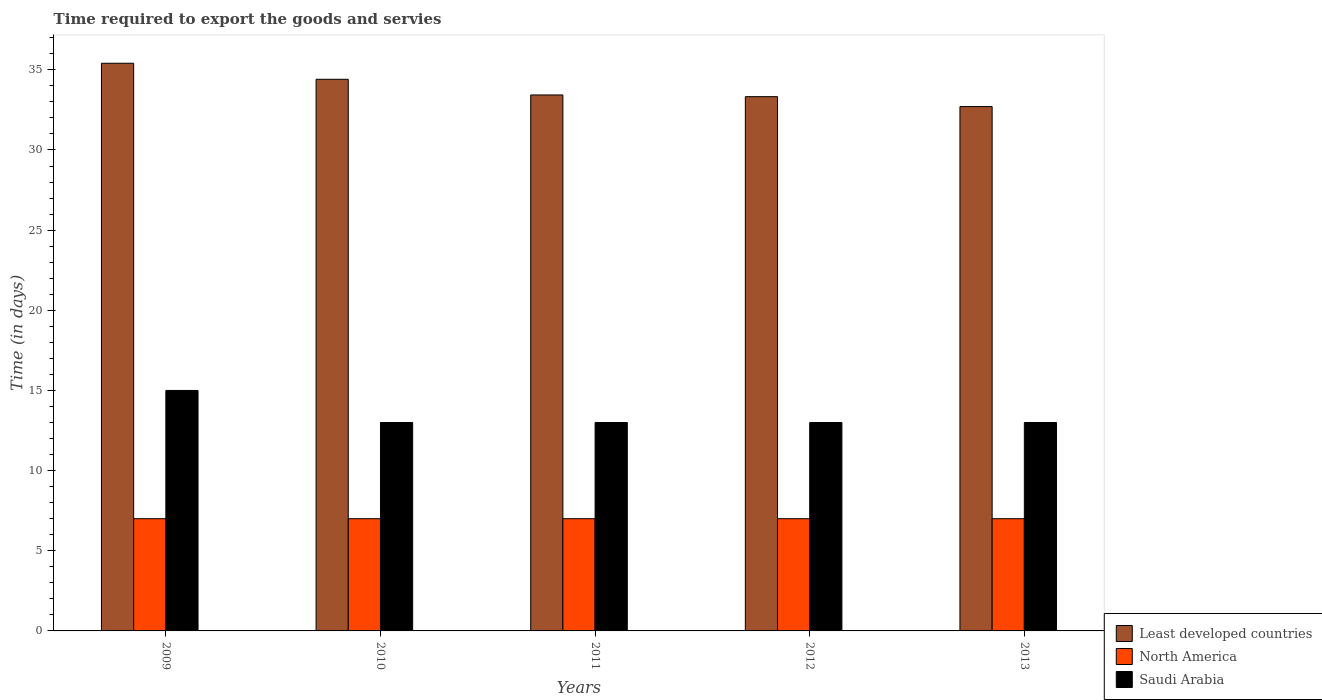How many different coloured bars are there?
Give a very brief answer. 3. How many groups of bars are there?
Keep it short and to the point. 5. Are the number of bars per tick equal to the number of legend labels?
Your answer should be compact. Yes. Are the number of bars on each tick of the X-axis equal?
Your answer should be very brief. Yes. How many bars are there on the 2nd tick from the left?
Your answer should be very brief. 3. What is the number of days required to export the goods and services in North America in 2011?
Keep it short and to the point. 7. Across all years, what is the maximum number of days required to export the goods and services in Saudi Arabia?
Provide a short and direct response. 15. Across all years, what is the minimum number of days required to export the goods and services in Saudi Arabia?
Your response must be concise. 13. In which year was the number of days required to export the goods and services in Saudi Arabia maximum?
Your response must be concise. 2009. In which year was the number of days required to export the goods and services in Saudi Arabia minimum?
Make the answer very short. 2010. What is the total number of days required to export the goods and services in North America in the graph?
Your response must be concise. 35. What is the average number of days required to export the goods and services in Least developed countries per year?
Ensure brevity in your answer.  33.86. In the year 2009, what is the difference between the number of days required to export the goods and services in Saudi Arabia and number of days required to export the goods and services in North America?
Make the answer very short. 8. In how many years, is the number of days required to export the goods and services in Least developed countries greater than 30 days?
Provide a short and direct response. 5. What is the ratio of the number of days required to export the goods and services in Saudi Arabia in 2009 to that in 2012?
Provide a short and direct response. 1.15. What is the difference between the highest and the lowest number of days required to export the goods and services in Saudi Arabia?
Give a very brief answer. 2. Is the sum of the number of days required to export the goods and services in Least developed countries in 2011 and 2012 greater than the maximum number of days required to export the goods and services in Saudi Arabia across all years?
Provide a succinct answer. Yes. What does the 1st bar from the left in 2010 represents?
Keep it short and to the point. Least developed countries. What does the 1st bar from the right in 2011 represents?
Make the answer very short. Saudi Arabia. How many bars are there?
Your answer should be very brief. 15. Are all the bars in the graph horizontal?
Keep it short and to the point. No. How many years are there in the graph?
Your response must be concise. 5. What is the difference between two consecutive major ticks on the Y-axis?
Keep it short and to the point. 5. Are the values on the major ticks of Y-axis written in scientific E-notation?
Provide a succinct answer. No. Does the graph contain any zero values?
Make the answer very short. No. Does the graph contain grids?
Offer a very short reply. No. Where does the legend appear in the graph?
Your response must be concise. Bottom right. How many legend labels are there?
Offer a very short reply. 3. How are the legend labels stacked?
Provide a succinct answer. Vertical. What is the title of the graph?
Provide a short and direct response. Time required to export the goods and servies. What is the label or title of the Y-axis?
Ensure brevity in your answer.  Time (in days). What is the Time (in days) of Least developed countries in 2009?
Ensure brevity in your answer.  35.41. What is the Time (in days) of North America in 2009?
Your answer should be very brief. 7. What is the Time (in days) of Least developed countries in 2010?
Ensure brevity in your answer.  34.41. What is the Time (in days) of North America in 2010?
Your answer should be compact. 7. What is the Time (in days) of Saudi Arabia in 2010?
Provide a short and direct response. 13. What is the Time (in days) in Least developed countries in 2011?
Give a very brief answer. 33.43. What is the Time (in days) of North America in 2011?
Offer a terse response. 7. What is the Time (in days) of Least developed countries in 2012?
Your answer should be very brief. 33.33. What is the Time (in days) in Least developed countries in 2013?
Provide a short and direct response. 32.71. What is the Time (in days) in North America in 2013?
Offer a very short reply. 7. What is the Time (in days) in Saudi Arabia in 2013?
Offer a very short reply. 13. Across all years, what is the maximum Time (in days) in Least developed countries?
Your answer should be very brief. 35.41. Across all years, what is the minimum Time (in days) in Least developed countries?
Keep it short and to the point. 32.71. What is the total Time (in days) in Least developed countries in the graph?
Make the answer very short. 169.28. What is the total Time (in days) of North America in the graph?
Keep it short and to the point. 35. What is the total Time (in days) in Saudi Arabia in the graph?
Your answer should be compact. 67. What is the difference between the Time (in days) in Least developed countries in 2009 and that in 2010?
Keep it short and to the point. 1. What is the difference between the Time (in days) of Saudi Arabia in 2009 and that in 2010?
Provide a succinct answer. 2. What is the difference between the Time (in days) of Least developed countries in 2009 and that in 2011?
Give a very brief answer. 1.98. What is the difference between the Time (in days) of Least developed countries in 2009 and that in 2012?
Ensure brevity in your answer.  2.08. What is the difference between the Time (in days) in Saudi Arabia in 2009 and that in 2012?
Offer a very short reply. 2. What is the difference between the Time (in days) of Least developed countries in 2009 and that in 2013?
Offer a terse response. 2.7. What is the difference between the Time (in days) in North America in 2009 and that in 2013?
Provide a succinct answer. 0. What is the difference between the Time (in days) of Least developed countries in 2010 and that in 2011?
Your answer should be compact. 0.98. What is the difference between the Time (in days) of North America in 2010 and that in 2011?
Make the answer very short. 0. What is the difference between the Time (in days) of Least developed countries in 2010 and that in 2012?
Keep it short and to the point. 1.08. What is the difference between the Time (in days) of Saudi Arabia in 2010 and that in 2012?
Provide a succinct answer. 0. What is the difference between the Time (in days) in Least developed countries in 2010 and that in 2013?
Your answer should be very brief. 1.7. What is the difference between the Time (in days) in Saudi Arabia in 2010 and that in 2013?
Make the answer very short. 0. What is the difference between the Time (in days) in Least developed countries in 2011 and that in 2012?
Offer a terse response. 0.11. What is the difference between the Time (in days) in Saudi Arabia in 2011 and that in 2012?
Offer a terse response. 0. What is the difference between the Time (in days) in Least developed countries in 2011 and that in 2013?
Your answer should be very brief. 0.72. What is the difference between the Time (in days) in North America in 2011 and that in 2013?
Offer a very short reply. 0. What is the difference between the Time (in days) in Least developed countries in 2012 and that in 2013?
Provide a short and direct response. 0.62. What is the difference between the Time (in days) of North America in 2012 and that in 2013?
Make the answer very short. 0. What is the difference between the Time (in days) of Least developed countries in 2009 and the Time (in days) of North America in 2010?
Provide a succinct answer. 28.41. What is the difference between the Time (in days) of Least developed countries in 2009 and the Time (in days) of Saudi Arabia in 2010?
Offer a terse response. 22.41. What is the difference between the Time (in days) in Least developed countries in 2009 and the Time (in days) in North America in 2011?
Offer a very short reply. 28.41. What is the difference between the Time (in days) of Least developed countries in 2009 and the Time (in days) of Saudi Arabia in 2011?
Provide a succinct answer. 22.41. What is the difference between the Time (in days) in Least developed countries in 2009 and the Time (in days) in North America in 2012?
Offer a terse response. 28.41. What is the difference between the Time (in days) in Least developed countries in 2009 and the Time (in days) in Saudi Arabia in 2012?
Give a very brief answer. 22.41. What is the difference between the Time (in days) in North America in 2009 and the Time (in days) in Saudi Arabia in 2012?
Your answer should be very brief. -6. What is the difference between the Time (in days) in Least developed countries in 2009 and the Time (in days) in North America in 2013?
Offer a terse response. 28.41. What is the difference between the Time (in days) in Least developed countries in 2009 and the Time (in days) in Saudi Arabia in 2013?
Ensure brevity in your answer.  22.41. What is the difference between the Time (in days) in Least developed countries in 2010 and the Time (in days) in North America in 2011?
Your response must be concise. 27.41. What is the difference between the Time (in days) in Least developed countries in 2010 and the Time (in days) in Saudi Arabia in 2011?
Offer a very short reply. 21.41. What is the difference between the Time (in days) in North America in 2010 and the Time (in days) in Saudi Arabia in 2011?
Give a very brief answer. -6. What is the difference between the Time (in days) of Least developed countries in 2010 and the Time (in days) of North America in 2012?
Ensure brevity in your answer.  27.41. What is the difference between the Time (in days) in Least developed countries in 2010 and the Time (in days) in Saudi Arabia in 2012?
Offer a terse response. 21.41. What is the difference between the Time (in days) in Least developed countries in 2010 and the Time (in days) in North America in 2013?
Your response must be concise. 27.41. What is the difference between the Time (in days) in Least developed countries in 2010 and the Time (in days) in Saudi Arabia in 2013?
Give a very brief answer. 21.41. What is the difference between the Time (in days) in Least developed countries in 2011 and the Time (in days) in North America in 2012?
Provide a succinct answer. 26.43. What is the difference between the Time (in days) in Least developed countries in 2011 and the Time (in days) in Saudi Arabia in 2012?
Provide a succinct answer. 20.43. What is the difference between the Time (in days) in Least developed countries in 2011 and the Time (in days) in North America in 2013?
Provide a short and direct response. 26.43. What is the difference between the Time (in days) in Least developed countries in 2011 and the Time (in days) in Saudi Arabia in 2013?
Offer a terse response. 20.43. What is the difference between the Time (in days) of Least developed countries in 2012 and the Time (in days) of North America in 2013?
Your answer should be compact. 26.33. What is the difference between the Time (in days) of Least developed countries in 2012 and the Time (in days) of Saudi Arabia in 2013?
Provide a short and direct response. 20.33. What is the difference between the Time (in days) of North America in 2012 and the Time (in days) of Saudi Arabia in 2013?
Ensure brevity in your answer.  -6. What is the average Time (in days) in Least developed countries per year?
Provide a succinct answer. 33.86. What is the average Time (in days) in North America per year?
Give a very brief answer. 7. In the year 2009, what is the difference between the Time (in days) in Least developed countries and Time (in days) in North America?
Provide a short and direct response. 28.41. In the year 2009, what is the difference between the Time (in days) of Least developed countries and Time (in days) of Saudi Arabia?
Offer a terse response. 20.41. In the year 2009, what is the difference between the Time (in days) of North America and Time (in days) of Saudi Arabia?
Your answer should be very brief. -8. In the year 2010, what is the difference between the Time (in days) of Least developed countries and Time (in days) of North America?
Provide a short and direct response. 27.41. In the year 2010, what is the difference between the Time (in days) in Least developed countries and Time (in days) in Saudi Arabia?
Offer a terse response. 21.41. In the year 2010, what is the difference between the Time (in days) in North America and Time (in days) in Saudi Arabia?
Your answer should be compact. -6. In the year 2011, what is the difference between the Time (in days) in Least developed countries and Time (in days) in North America?
Offer a very short reply. 26.43. In the year 2011, what is the difference between the Time (in days) in Least developed countries and Time (in days) in Saudi Arabia?
Your answer should be compact. 20.43. In the year 2011, what is the difference between the Time (in days) in North America and Time (in days) in Saudi Arabia?
Offer a very short reply. -6. In the year 2012, what is the difference between the Time (in days) in Least developed countries and Time (in days) in North America?
Keep it short and to the point. 26.33. In the year 2012, what is the difference between the Time (in days) of Least developed countries and Time (in days) of Saudi Arabia?
Offer a very short reply. 20.33. In the year 2013, what is the difference between the Time (in days) of Least developed countries and Time (in days) of North America?
Your response must be concise. 25.71. In the year 2013, what is the difference between the Time (in days) in Least developed countries and Time (in days) in Saudi Arabia?
Give a very brief answer. 19.71. What is the ratio of the Time (in days) of Least developed countries in 2009 to that in 2010?
Provide a succinct answer. 1.03. What is the ratio of the Time (in days) in Saudi Arabia in 2009 to that in 2010?
Offer a terse response. 1.15. What is the ratio of the Time (in days) in Least developed countries in 2009 to that in 2011?
Offer a terse response. 1.06. What is the ratio of the Time (in days) in North America in 2009 to that in 2011?
Keep it short and to the point. 1. What is the ratio of the Time (in days) of Saudi Arabia in 2009 to that in 2011?
Keep it short and to the point. 1.15. What is the ratio of the Time (in days) in Least developed countries in 2009 to that in 2012?
Offer a very short reply. 1.06. What is the ratio of the Time (in days) of Saudi Arabia in 2009 to that in 2012?
Provide a succinct answer. 1.15. What is the ratio of the Time (in days) of Least developed countries in 2009 to that in 2013?
Provide a short and direct response. 1.08. What is the ratio of the Time (in days) of North America in 2009 to that in 2013?
Offer a terse response. 1. What is the ratio of the Time (in days) of Saudi Arabia in 2009 to that in 2013?
Ensure brevity in your answer.  1.15. What is the ratio of the Time (in days) of Least developed countries in 2010 to that in 2011?
Give a very brief answer. 1.03. What is the ratio of the Time (in days) of Saudi Arabia in 2010 to that in 2011?
Offer a terse response. 1. What is the ratio of the Time (in days) in Least developed countries in 2010 to that in 2012?
Give a very brief answer. 1.03. What is the ratio of the Time (in days) in North America in 2010 to that in 2012?
Ensure brevity in your answer.  1. What is the ratio of the Time (in days) in Least developed countries in 2010 to that in 2013?
Offer a terse response. 1.05. What is the ratio of the Time (in days) in Least developed countries in 2011 to that in 2012?
Keep it short and to the point. 1. What is the ratio of the Time (in days) of Least developed countries in 2011 to that in 2013?
Offer a terse response. 1.02. What is the ratio of the Time (in days) in Saudi Arabia in 2011 to that in 2013?
Provide a succinct answer. 1. What is the ratio of the Time (in days) in Least developed countries in 2012 to that in 2013?
Make the answer very short. 1.02. What is the ratio of the Time (in days) in North America in 2012 to that in 2013?
Keep it short and to the point. 1. What is the ratio of the Time (in days) of Saudi Arabia in 2012 to that in 2013?
Give a very brief answer. 1. What is the difference between the highest and the second highest Time (in days) in Least developed countries?
Make the answer very short. 1. What is the difference between the highest and the second highest Time (in days) in North America?
Provide a succinct answer. 0. What is the difference between the highest and the lowest Time (in days) in Least developed countries?
Your answer should be very brief. 2.7. 